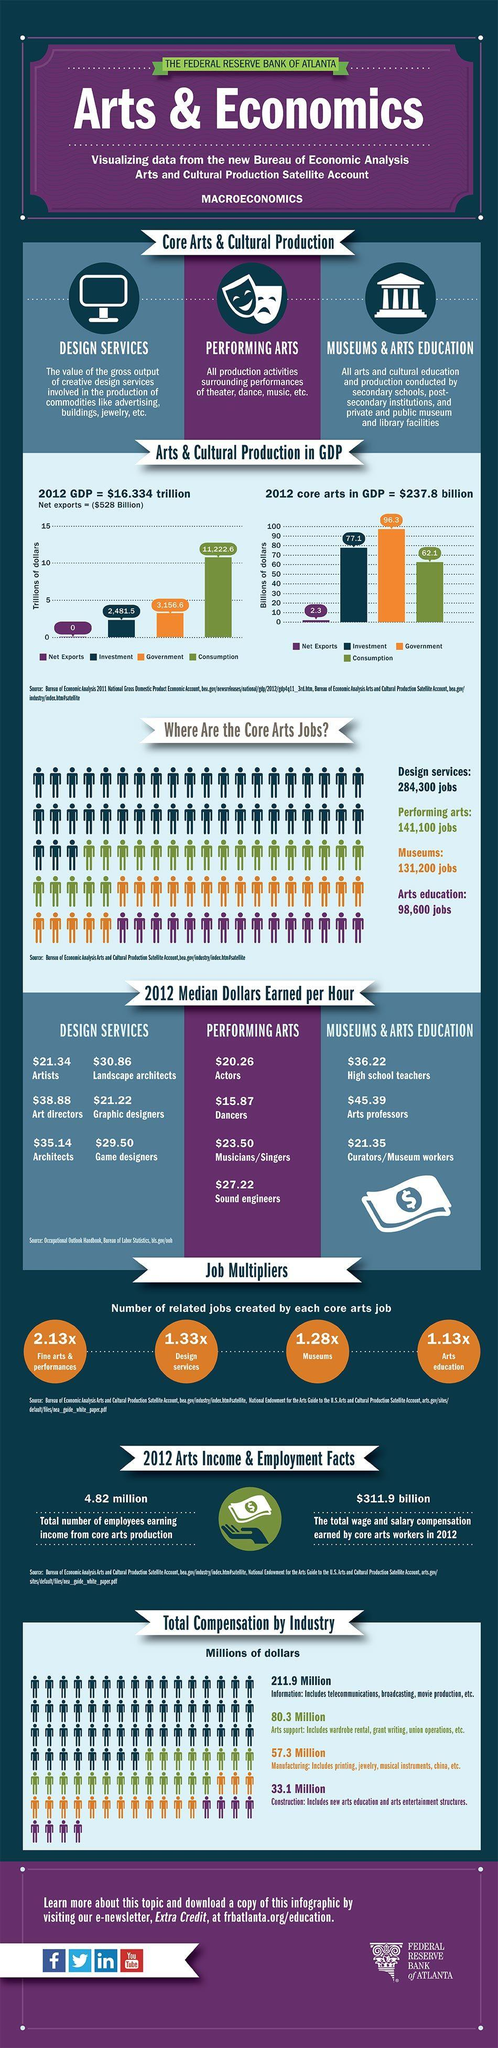Give some essential details in this illustration. Dancers belong to the category of performing arts. In 2012, the wage and salary compensation earned by core arts workers amounted to a total of $311.9 billion. Graphic designers earn approximately $21.22 per hour on average. In which area are there more core art jobs opportunities in the field of design services? The difference in the number of job availability in design services and performing arts is 143,200. 